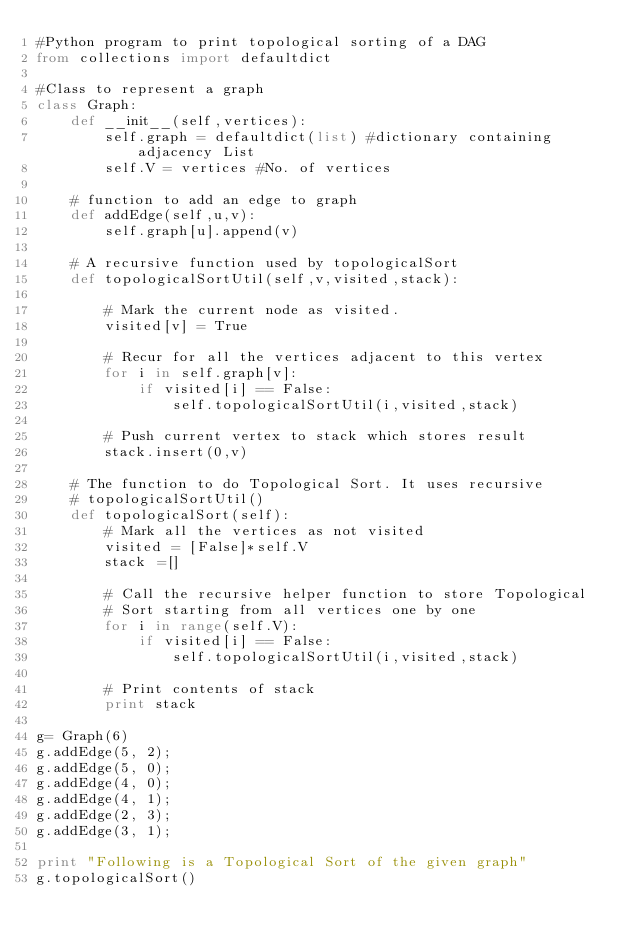<code> <loc_0><loc_0><loc_500><loc_500><_Python_>#Python program to print topological sorting of a DAG
from collections import defaultdict
 
#Class to represent a graph
class Graph:
    def __init__(self,vertices):
        self.graph = defaultdict(list) #dictionary containing adjacency List
        self.V = vertices #No. of vertices
 
    # function to add an edge to graph
    def addEdge(self,u,v):
        self.graph[u].append(v)
 
    # A recursive function used by topologicalSort
    def topologicalSortUtil(self,v,visited,stack):
 
        # Mark the current node as visited.
        visited[v] = True
 
        # Recur for all the vertices adjacent to this vertex
        for i in self.graph[v]:
            if visited[i] == False:
                self.topologicalSortUtil(i,visited,stack)
 
        # Push current vertex to stack which stores result
        stack.insert(0,v)
 
    # The function to do Topological Sort. It uses recursive 
    # topologicalSortUtil()
    def topologicalSort(self):
        # Mark all the vertices as not visited
        visited = [False]*self.V
        stack =[]
 
        # Call the recursive helper function to store Topological
        # Sort starting from all vertices one by one
        for i in range(self.V):
            if visited[i] == False:
                self.topologicalSortUtil(i,visited,stack)
 
        # Print contents of stack
        print stack
 
g= Graph(6)
g.addEdge(5, 2);
g.addEdge(5, 0);
g.addEdge(4, 0);
g.addEdge(4, 1);
g.addEdge(2, 3);
g.addEdge(3, 1);
 
print "Following is a Topological Sort of the given graph"
g.topologicalSort()</code> 